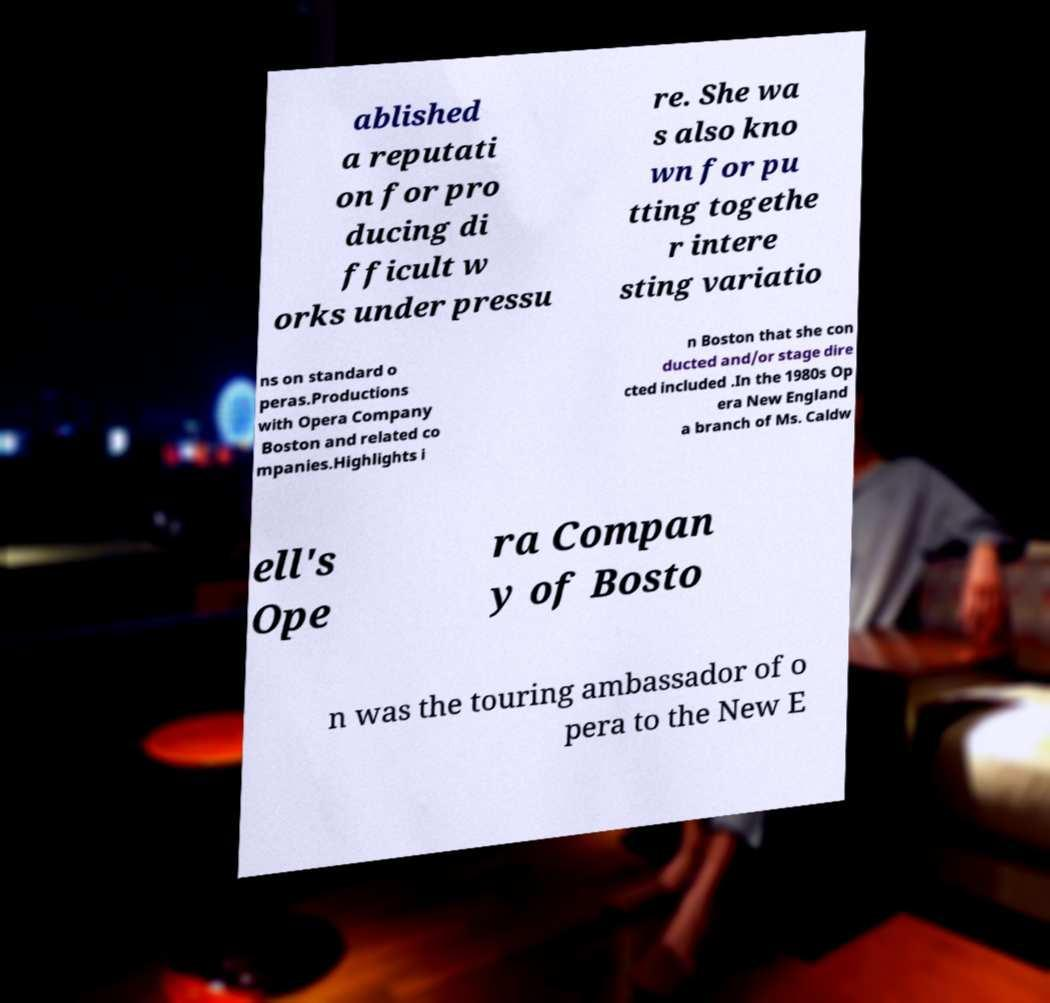Please read and relay the text visible in this image. What does it say? ablished a reputati on for pro ducing di fficult w orks under pressu re. She wa s also kno wn for pu tting togethe r intere sting variatio ns on standard o peras.Productions with Opera Company Boston and related co mpanies.Highlights i n Boston that she con ducted and/or stage dire cted included .In the 1980s Op era New England a branch of Ms. Caldw ell's Ope ra Compan y of Bosto n was the touring ambassador of o pera to the New E 